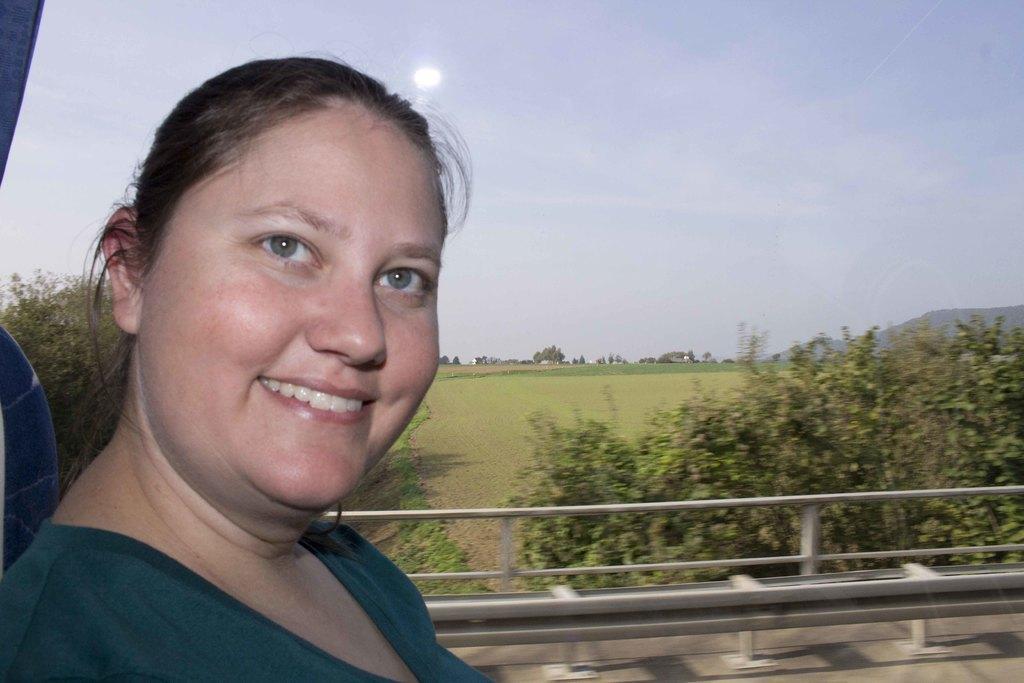Can you describe this image briefly? In the foreground of this picture, there is a woman sitting and having smile on her face. In the background, through glass we can see plants, grass, trees, mountain and the sky. 